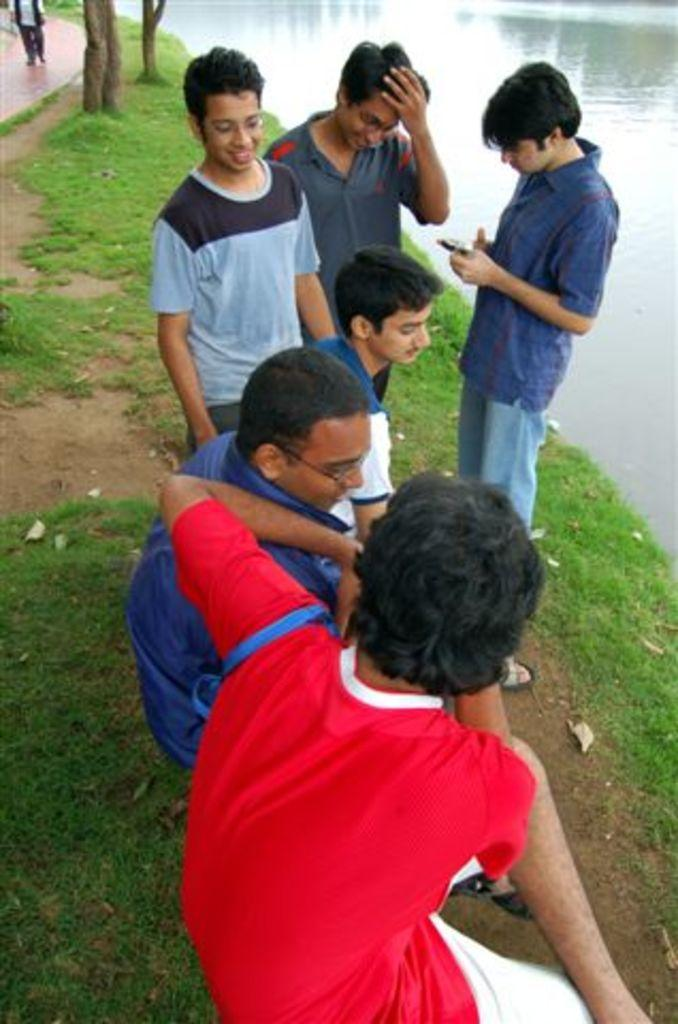What is the main subject of the image? The main subject of the image is a group of people. What can be seen in the background of the image? There is water visible in the image, and the land is covered with grass. Can you describe the location of the person who is far from the group of people? There is a person far from the group of people in the image. What type of magic is being performed by the group of people in the image? There is no indication of magic or any magical activity in the image. The group of people is simply present in the image, and there is no evidence of any magical performance. 